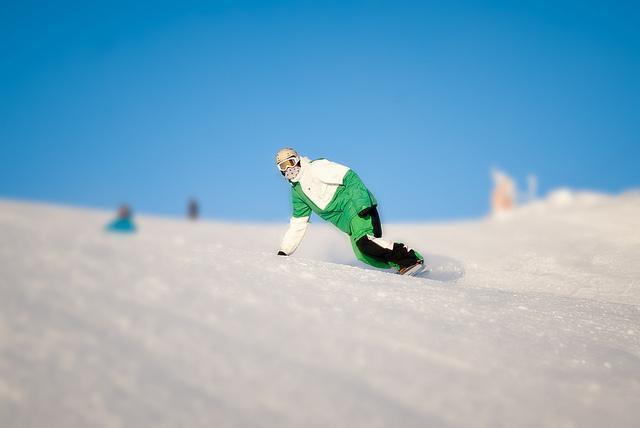The item the person is wearing on their face looks like what?
Answer the question by selecting the correct answer among the 4 following choices.
Options: Chicken, gas mask, frog, scarf. Gas mask. 